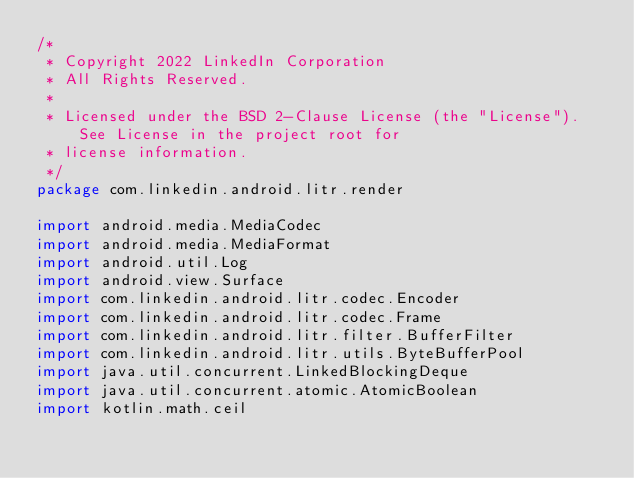Convert code to text. <code><loc_0><loc_0><loc_500><loc_500><_Kotlin_>/*
 * Copyright 2022 LinkedIn Corporation
 * All Rights Reserved.
 *
 * Licensed under the BSD 2-Clause License (the "License").  See License in the project root for
 * license information.
 */
package com.linkedin.android.litr.render

import android.media.MediaCodec
import android.media.MediaFormat
import android.util.Log
import android.view.Surface
import com.linkedin.android.litr.codec.Encoder
import com.linkedin.android.litr.codec.Frame
import com.linkedin.android.litr.filter.BufferFilter
import com.linkedin.android.litr.utils.ByteBufferPool
import java.util.concurrent.LinkedBlockingDeque
import java.util.concurrent.atomic.AtomicBoolean
import kotlin.math.ceil
</code> 